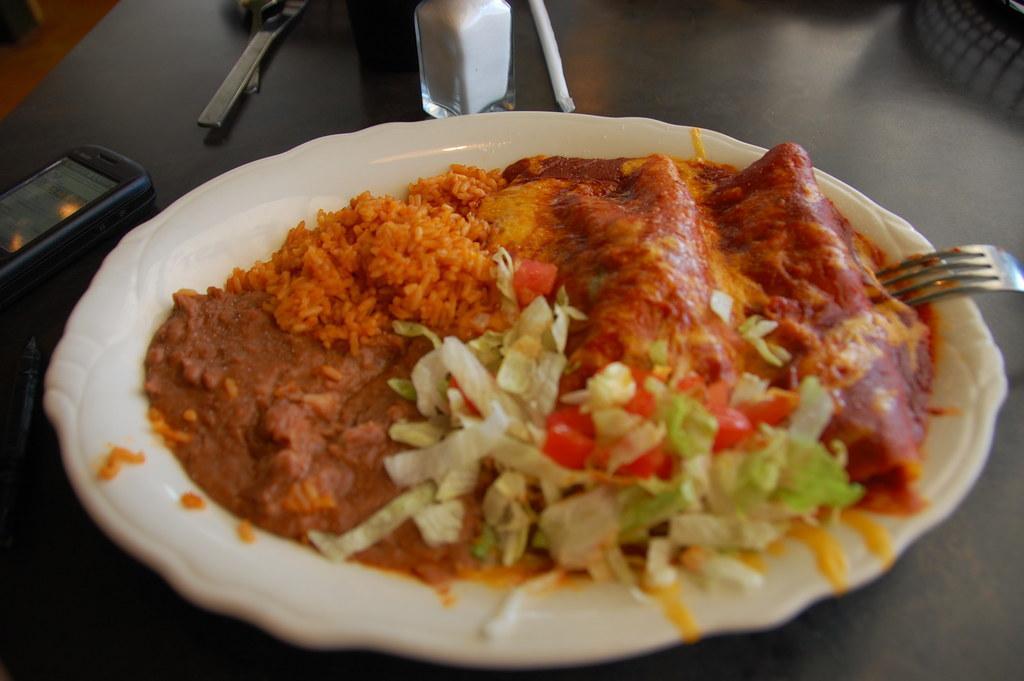Please provide a concise description of this image. In the image in the center there is a table. On the table,we can see one jar,phone,fork,plate,some food item and few other objects. 